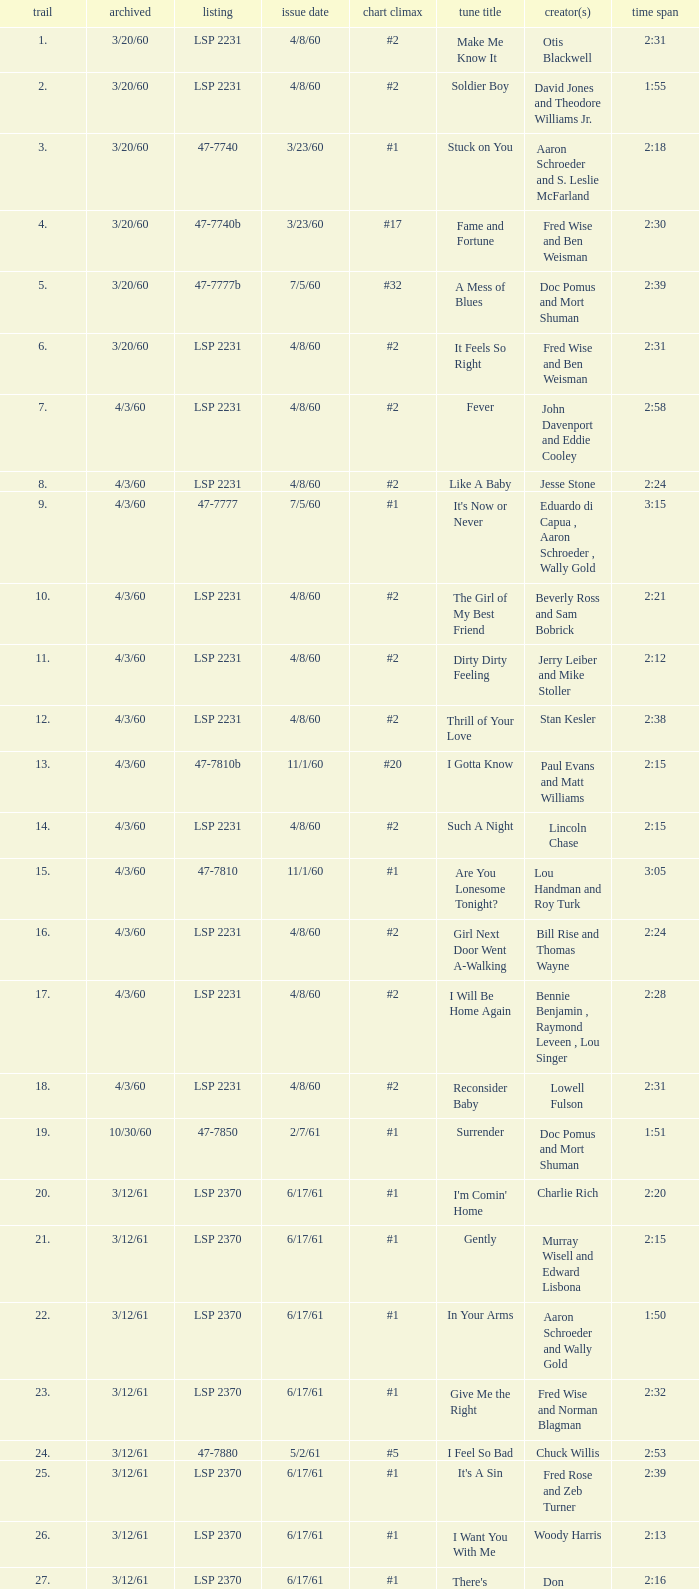Parse the table in full. {'header': ['trail', 'archived', 'listing', 'issue date', 'chart climax', 'tune title', 'creator(s)', 'time span'], 'rows': [['1.', '3/20/60', 'LSP 2231', '4/8/60', '#2', 'Make Me Know It', 'Otis Blackwell', '2:31'], ['2.', '3/20/60', 'LSP 2231', '4/8/60', '#2', 'Soldier Boy', 'David Jones and Theodore Williams Jr.', '1:55'], ['3.', '3/20/60', '47-7740', '3/23/60', '#1', 'Stuck on You', 'Aaron Schroeder and S. Leslie McFarland', '2:18'], ['4.', '3/20/60', '47-7740b', '3/23/60', '#17', 'Fame and Fortune', 'Fred Wise and Ben Weisman', '2:30'], ['5.', '3/20/60', '47-7777b', '7/5/60', '#32', 'A Mess of Blues', 'Doc Pomus and Mort Shuman', '2:39'], ['6.', '3/20/60', 'LSP 2231', '4/8/60', '#2', 'It Feels So Right', 'Fred Wise and Ben Weisman', '2:31'], ['7.', '4/3/60', 'LSP 2231', '4/8/60', '#2', 'Fever', 'John Davenport and Eddie Cooley', '2:58'], ['8.', '4/3/60', 'LSP 2231', '4/8/60', '#2', 'Like A Baby', 'Jesse Stone', '2:24'], ['9.', '4/3/60', '47-7777', '7/5/60', '#1', "It's Now or Never", 'Eduardo di Capua , Aaron Schroeder , Wally Gold', '3:15'], ['10.', '4/3/60', 'LSP 2231', '4/8/60', '#2', 'The Girl of My Best Friend', 'Beverly Ross and Sam Bobrick', '2:21'], ['11.', '4/3/60', 'LSP 2231', '4/8/60', '#2', 'Dirty Dirty Feeling', 'Jerry Leiber and Mike Stoller', '2:12'], ['12.', '4/3/60', 'LSP 2231', '4/8/60', '#2', 'Thrill of Your Love', 'Stan Kesler', '2:38'], ['13.', '4/3/60', '47-7810b', '11/1/60', '#20', 'I Gotta Know', 'Paul Evans and Matt Williams', '2:15'], ['14.', '4/3/60', 'LSP 2231', '4/8/60', '#2', 'Such A Night', 'Lincoln Chase', '2:15'], ['15.', '4/3/60', '47-7810', '11/1/60', '#1', 'Are You Lonesome Tonight?', 'Lou Handman and Roy Turk', '3:05'], ['16.', '4/3/60', 'LSP 2231', '4/8/60', '#2', 'Girl Next Door Went A-Walking', 'Bill Rise and Thomas Wayne', '2:24'], ['17.', '4/3/60', 'LSP 2231', '4/8/60', '#2', 'I Will Be Home Again', 'Bennie Benjamin , Raymond Leveen , Lou Singer', '2:28'], ['18.', '4/3/60', 'LSP 2231', '4/8/60', '#2', 'Reconsider Baby', 'Lowell Fulson', '2:31'], ['19.', '10/30/60', '47-7850', '2/7/61', '#1', 'Surrender', 'Doc Pomus and Mort Shuman', '1:51'], ['20.', '3/12/61', 'LSP 2370', '6/17/61', '#1', "I'm Comin' Home", 'Charlie Rich', '2:20'], ['21.', '3/12/61', 'LSP 2370', '6/17/61', '#1', 'Gently', 'Murray Wisell and Edward Lisbona', '2:15'], ['22.', '3/12/61', 'LSP 2370', '6/17/61', '#1', 'In Your Arms', 'Aaron Schroeder and Wally Gold', '1:50'], ['23.', '3/12/61', 'LSP 2370', '6/17/61', '#1', 'Give Me the Right', 'Fred Wise and Norman Blagman', '2:32'], ['24.', '3/12/61', '47-7880', '5/2/61', '#5', 'I Feel So Bad', 'Chuck Willis', '2:53'], ['25.', '3/12/61', 'LSP 2370', '6/17/61', '#1', "It's A Sin", 'Fred Rose and Zeb Turner', '2:39'], ['26.', '3/12/61', 'LSP 2370', '6/17/61', '#1', 'I Want You With Me', 'Woody Harris', '2:13'], ['27.', '3/12/61', 'LSP 2370', '6/17/61', '#1', "There's Always Me", 'Don Robertson', '2:16']]} What is the time of songs that have the writer Aaron Schroeder and Wally Gold? 1:50. 